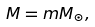<formula> <loc_0><loc_0><loc_500><loc_500>M = m M _ { \odot } ,</formula> 